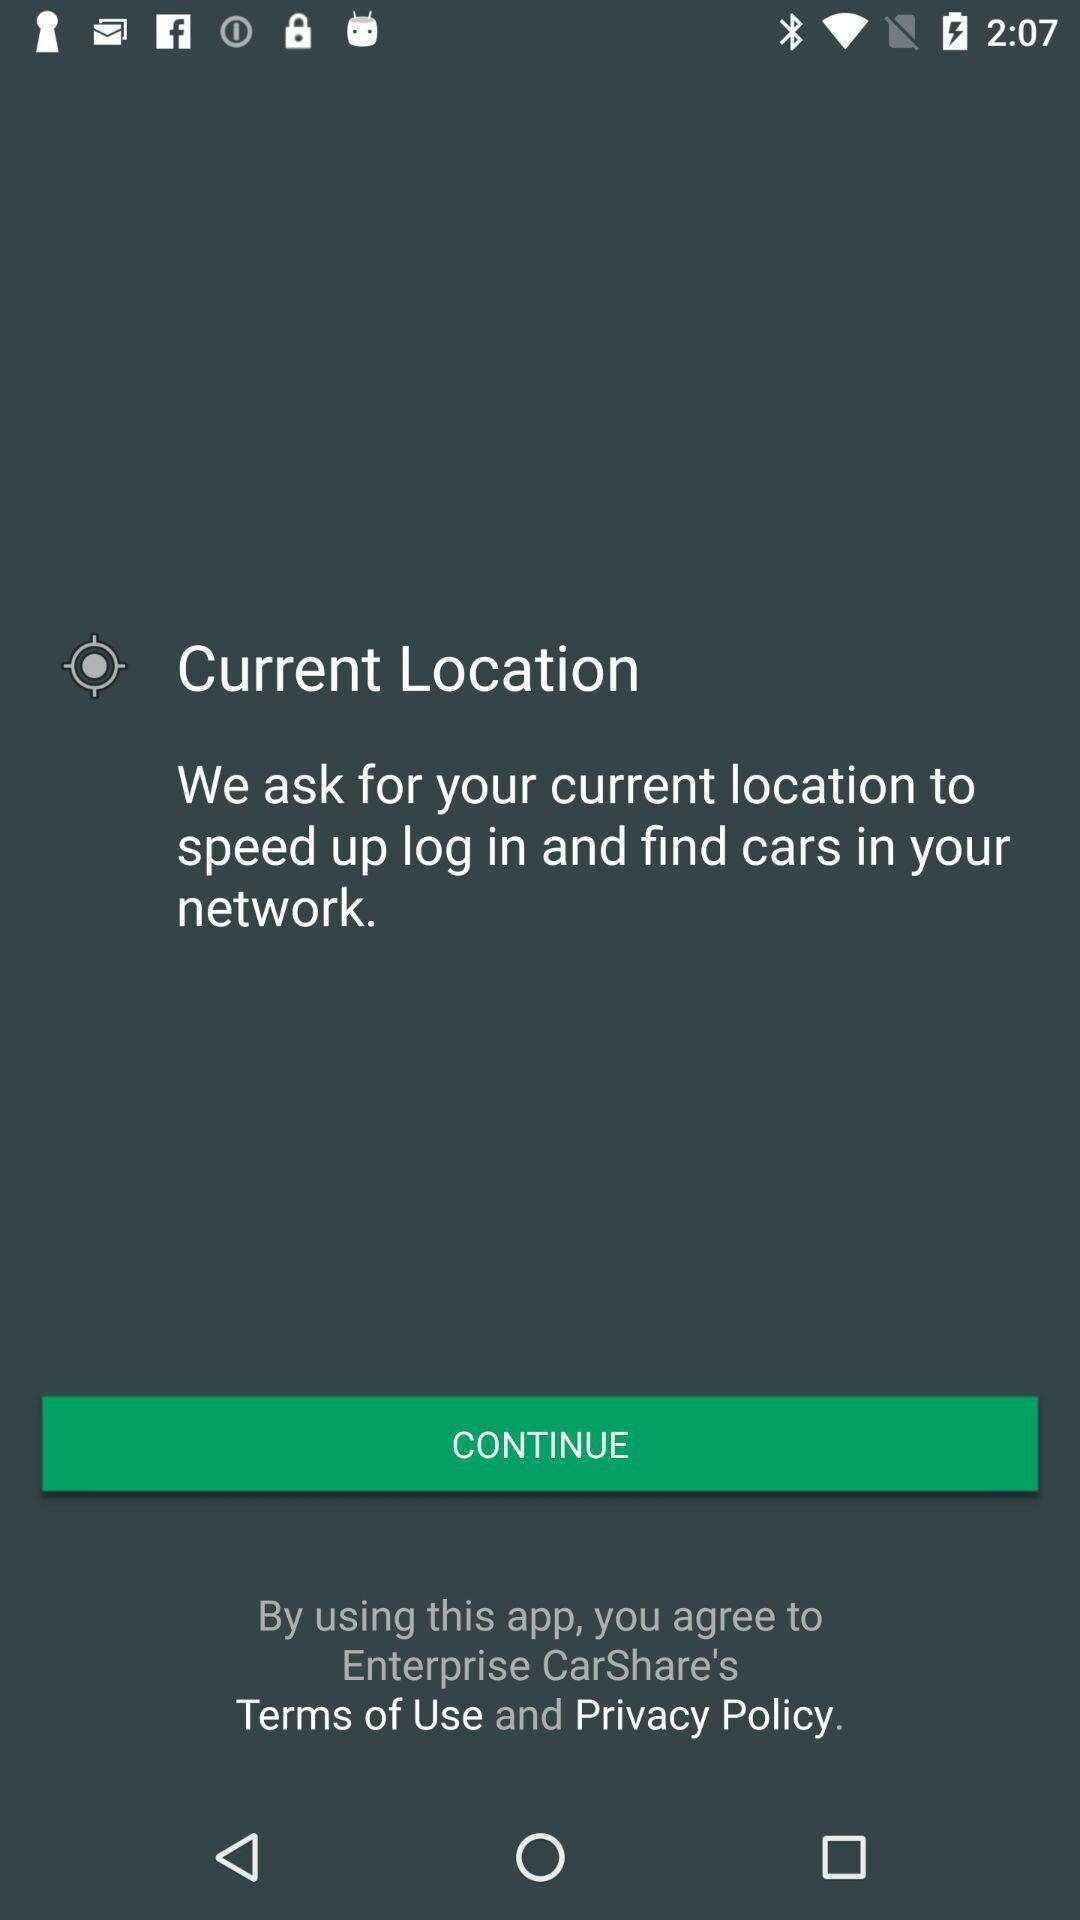Summarize the information in this screenshot. Window displaying a find car app. 